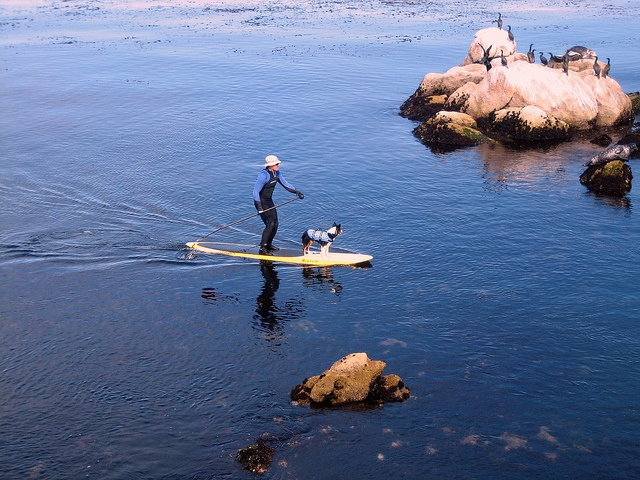Describe the objects in this image and their specific colors. I can see people in lavender, black, gray, and navy tones, surfboard in lavender, white, khaki, and gray tones, dog in lavender, lightgray, black, navy, and gray tones, bird in lavender, gray, black, lightgray, and lightpink tones, and bird in lavender, black, gray, navy, and purple tones in this image. 